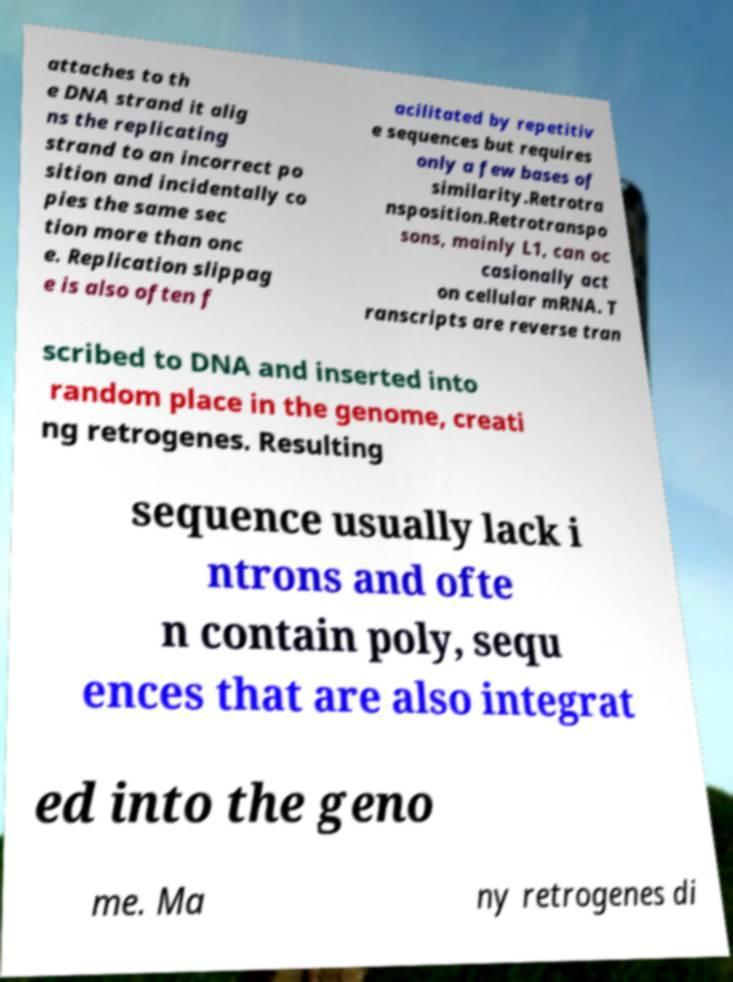Please identify and transcribe the text found in this image. attaches to th e DNA strand it alig ns the replicating strand to an incorrect po sition and incidentally co pies the same sec tion more than onc e. Replication slippag e is also often f acilitated by repetitiv e sequences but requires only a few bases of similarity.Retrotra nsposition.Retrotranspo sons, mainly L1, can oc casionally act on cellular mRNA. T ranscripts are reverse tran scribed to DNA and inserted into random place in the genome, creati ng retrogenes. Resulting sequence usually lack i ntrons and ofte n contain poly, sequ ences that are also integrat ed into the geno me. Ma ny retrogenes di 